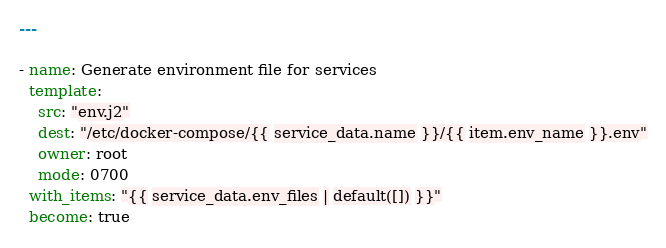Convert code to text. <code><loc_0><loc_0><loc_500><loc_500><_YAML_>---

- name: Generate environment file for services
  template:
    src: "env.j2"
    dest: "/etc/docker-compose/{{ service_data.name }}/{{ item.env_name }}.env"
    owner: root
    mode: 0700
  with_items: "{{ service_data.env_files | default([]) }}"
  become: true
</code> 